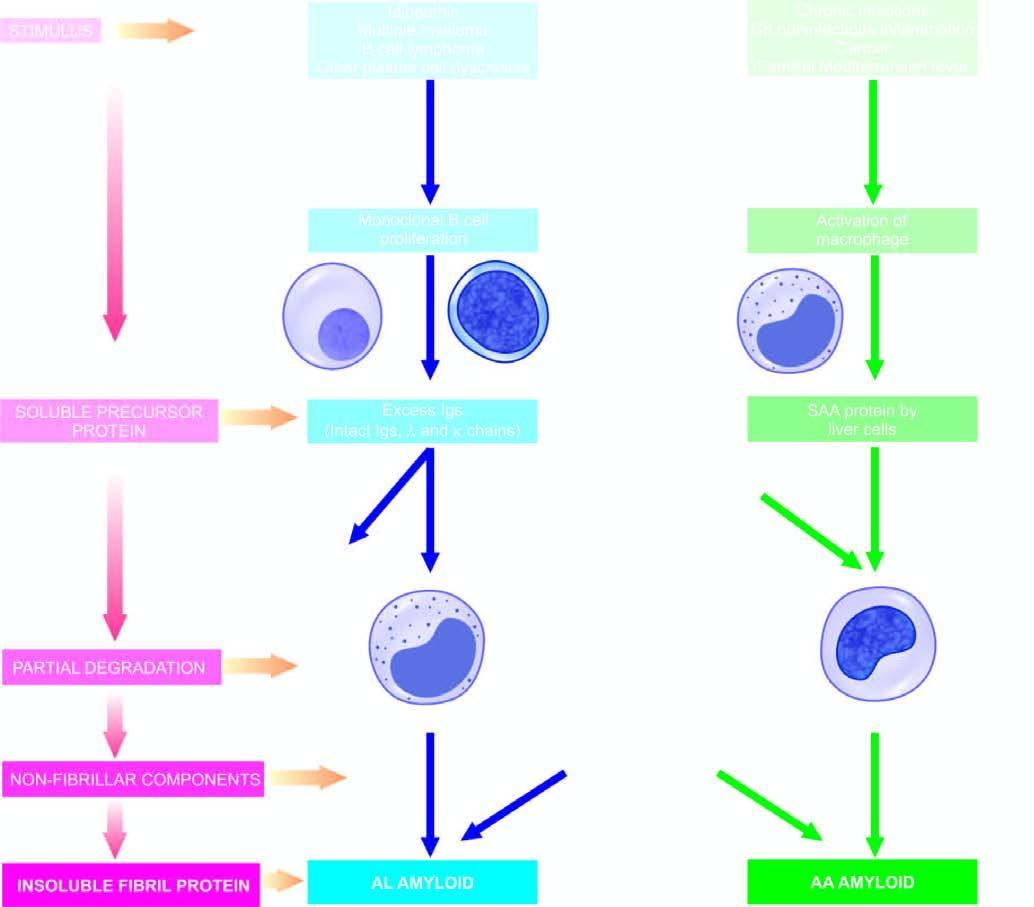what shows general schematic representation common to both major forms of amyloidogenesis?
Answer the question using a single word or phrase. The sequence on left 